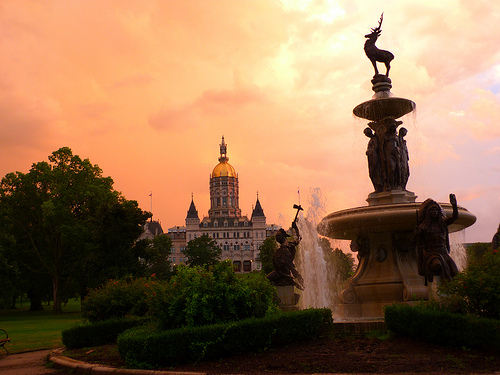<image>
Is the building next to the statue? No. The building is not positioned next to the statue. They are located in different areas of the scene. 